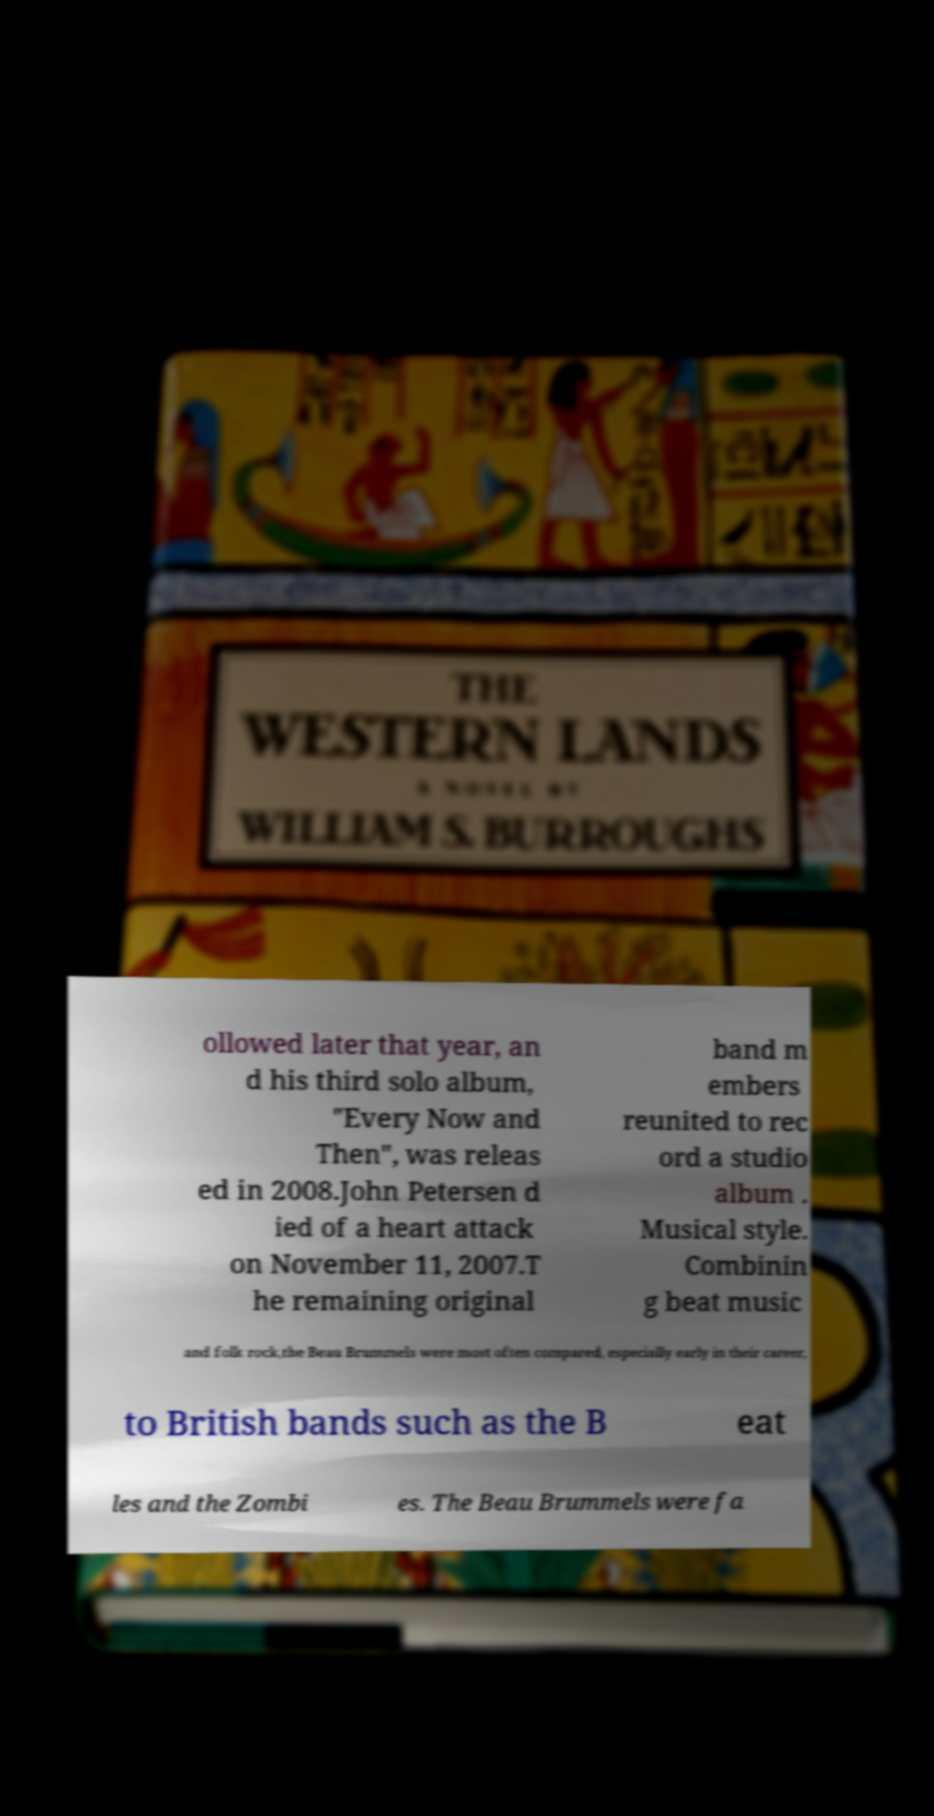Can you read and provide the text displayed in the image?This photo seems to have some interesting text. Can you extract and type it out for me? ollowed later that year, an d his third solo album, "Every Now and Then", was releas ed in 2008.John Petersen d ied of a heart attack on November 11, 2007.T he remaining original band m embers reunited to rec ord a studio album . Musical style. Combinin g beat music and folk rock,the Beau Brummels were most often compared, especially early in their career, to British bands such as the B eat les and the Zombi es. The Beau Brummels were fa 